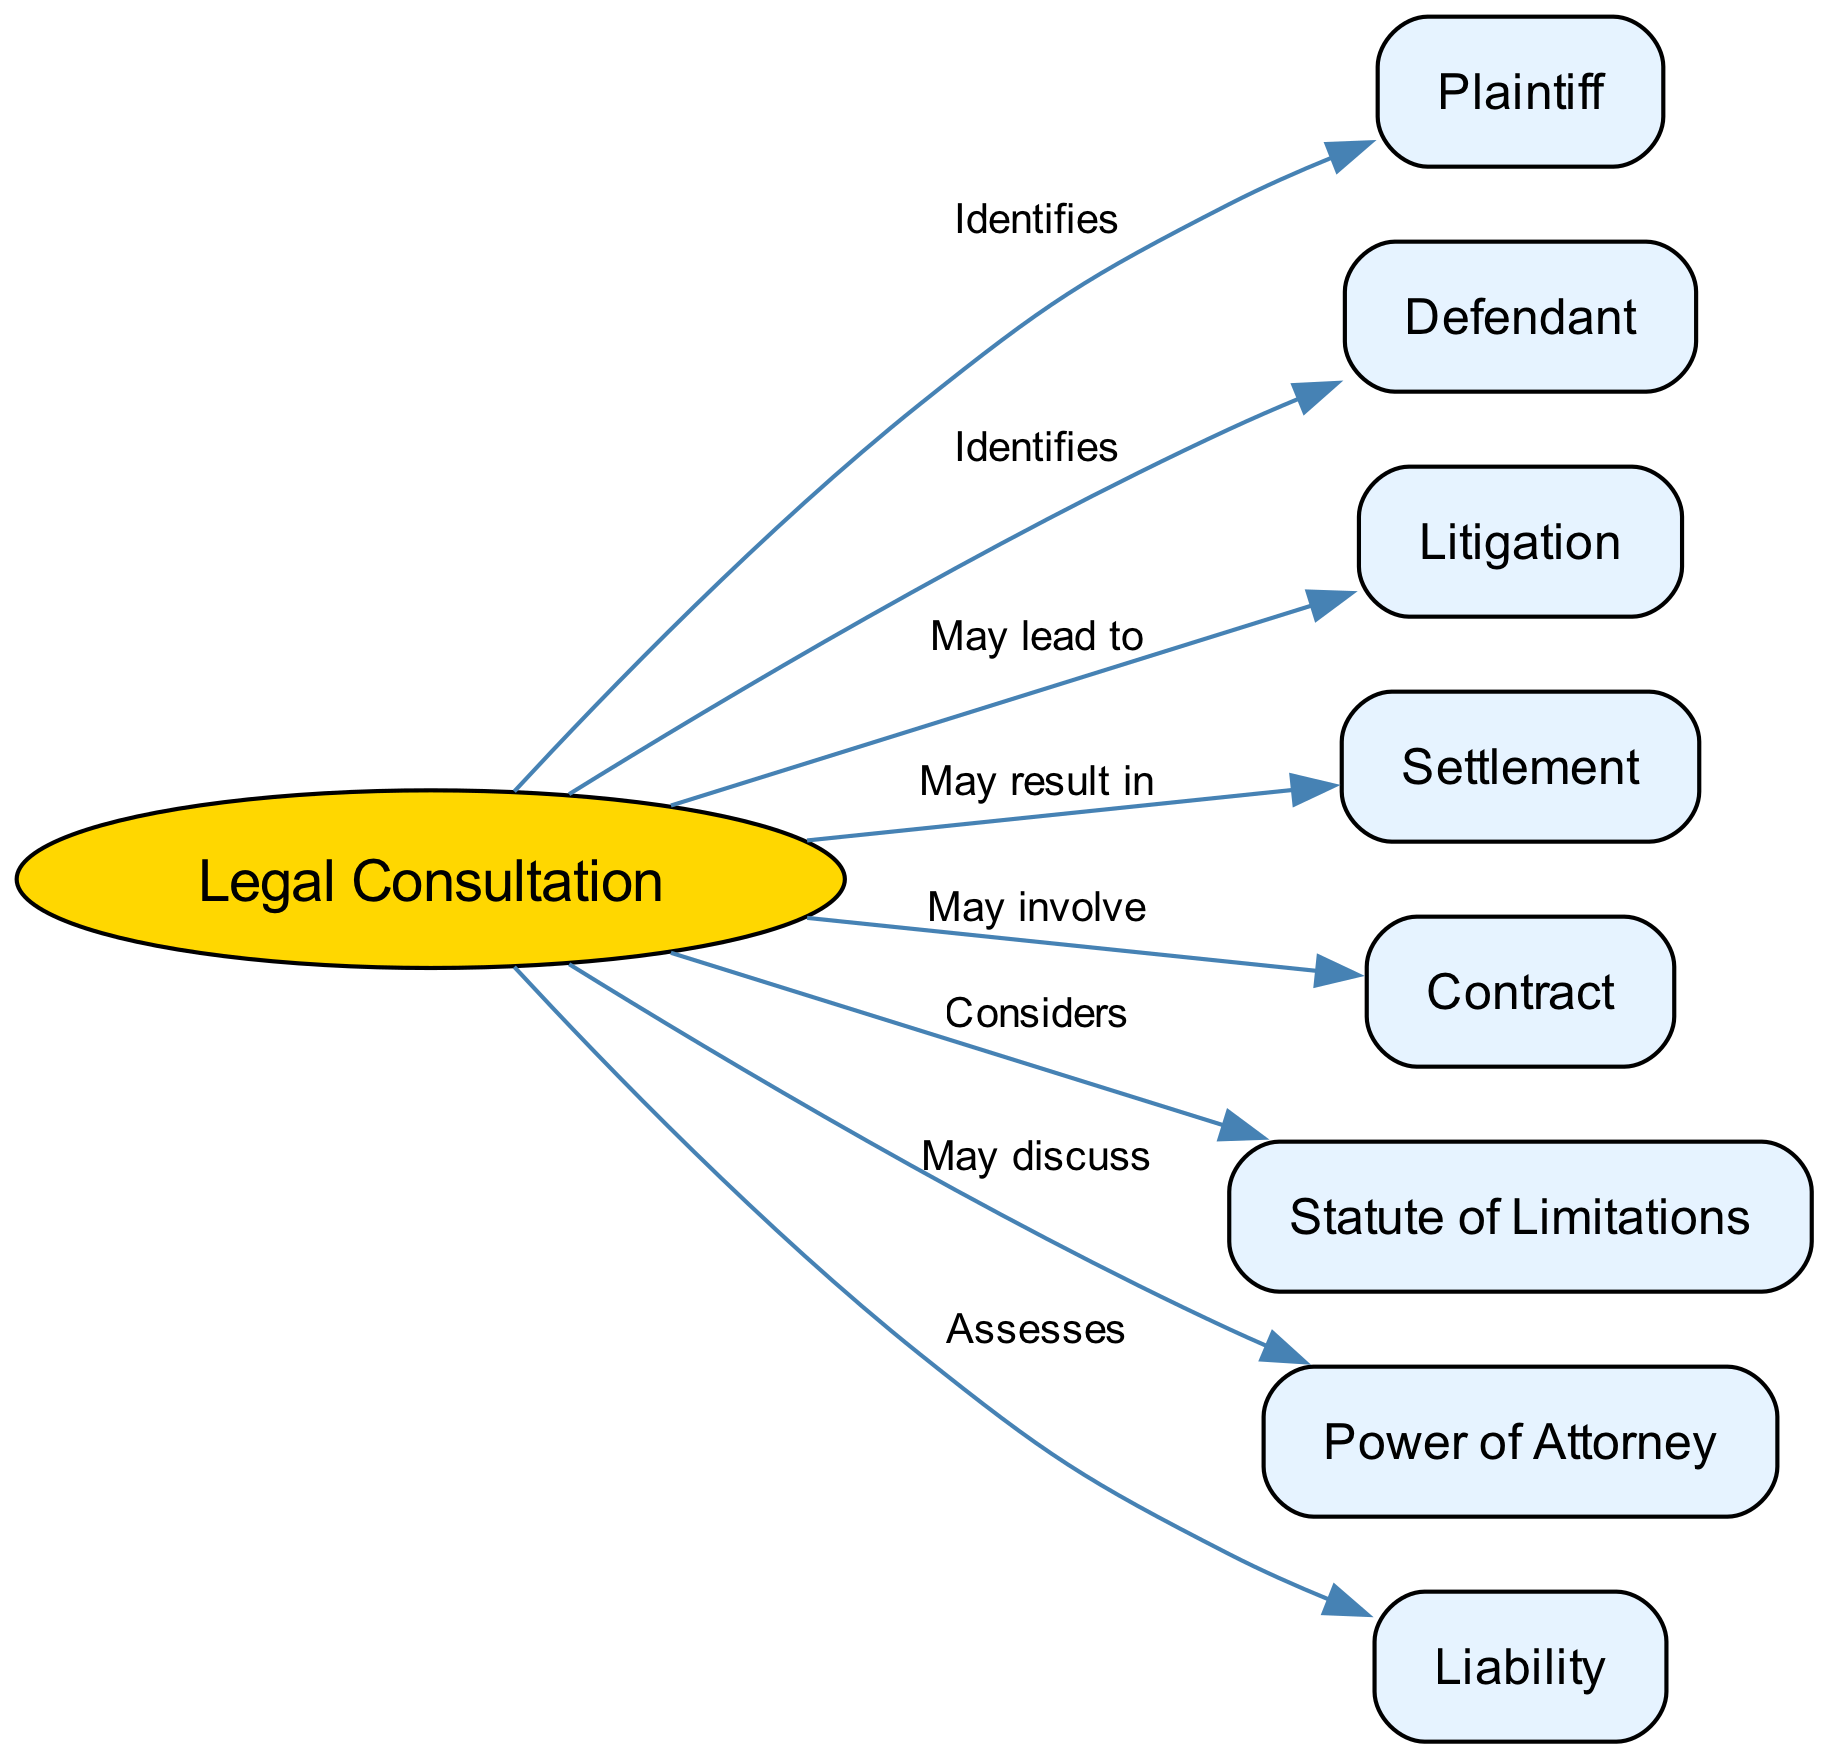What is the primary focus of the diagram? The diagram illustrates the key legal terms and their relationships used in legal consultations, centering on "Legal Consultation" as the main subject.
Answer: Legal Consultation How many nodes are represented in the diagram? Counting the individual entities presented in the diagram yields a total of 9 different nodes, which include legal terms and relevant concepts.
Answer: 9 What is the relationship between "Legal Consultation" and "Plaintiff"? The diagram shows that "Legal Consultation" identifies the "Plaintiff," indicating a direct link where the consultation process identifies the person who brings a case against another in a court.
Answer: Identifies Which term is associated with the concept of "Settlement"? According to the diagram, "Settlement" is a potential outcome of a "Legal Consultation," highlighting that it is one of the ways to resolve a legal dispute without proceeding to litigation.
Answer: May result in What considerations are linked to the "Statute of Limitations"? The diagram indicates that during a "Legal Consultation," the "Statute of Limitations" is considered, which refers to the legal time limits within which a case must be initiated.
Answer: Considers What do both "Plaintiff" and "Defendant" have in common? Both "Plaintiff" and "Defendant" are identified in the context of "Legal Consultation," suggesting that the consultation process involves recognizing both parties relevant to a legal matter.
Answer: Identifies How does "Legal Consultation" relate to "Litigation"? The diagram demonstrates that "Legal Consultation" may lead to "Litigation," suggesting that if the consultation does not resolve the matter, the next step could involve legal action in court.
Answer: May lead to What does "Liability" assess during "Legal Consultation"? It indicates the evaluation of responsibility or legal obligation in the context of potential legal issues, thus assessing any claims of liability involved in the case discussed during the consultation.
Answer: Assesses What might be discussed regarding "Power of Attorney"? The relationship shows that the "Legal Consultation" might involve discussions about the "Power of Attorney," which is the authority given to someone to act on behalf of another in legal or financial matters.
Answer: May discuss 